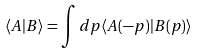<formula> <loc_0><loc_0><loc_500><loc_500>\langle A | B \rangle = \int d p \langle A ( - p ) | B ( p ) \rangle</formula> 